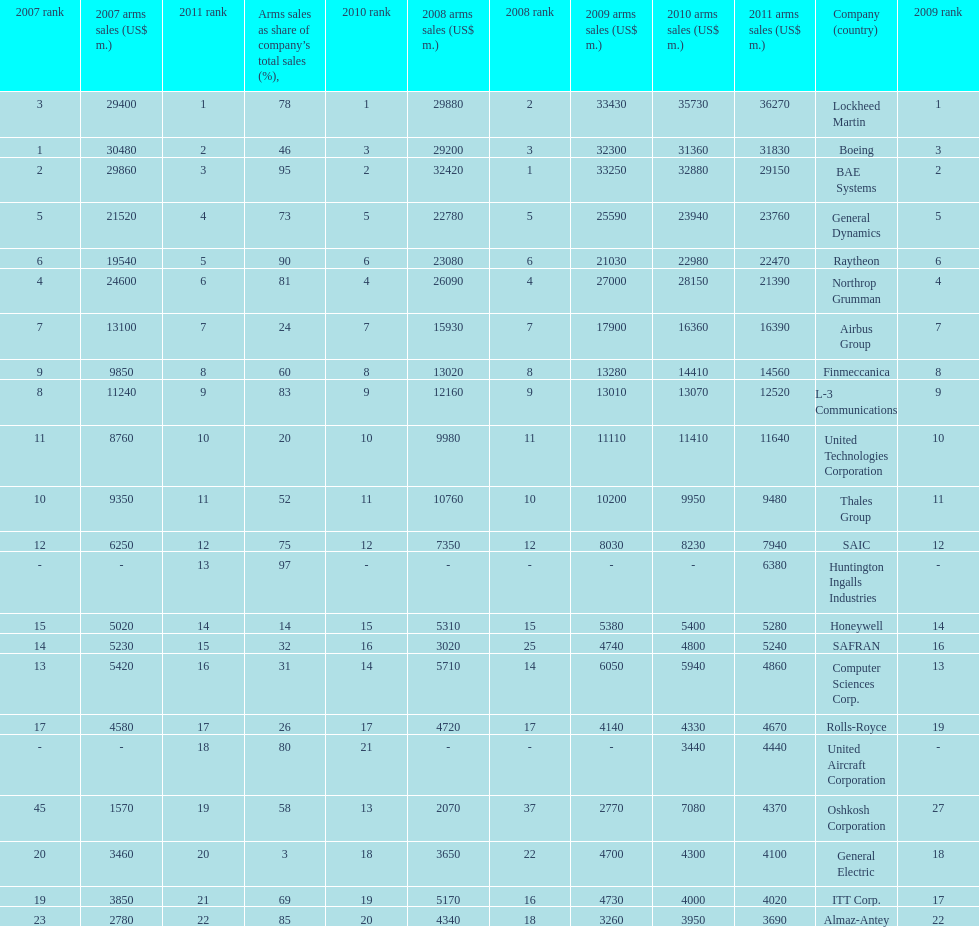How many different countries are listed? 6. 